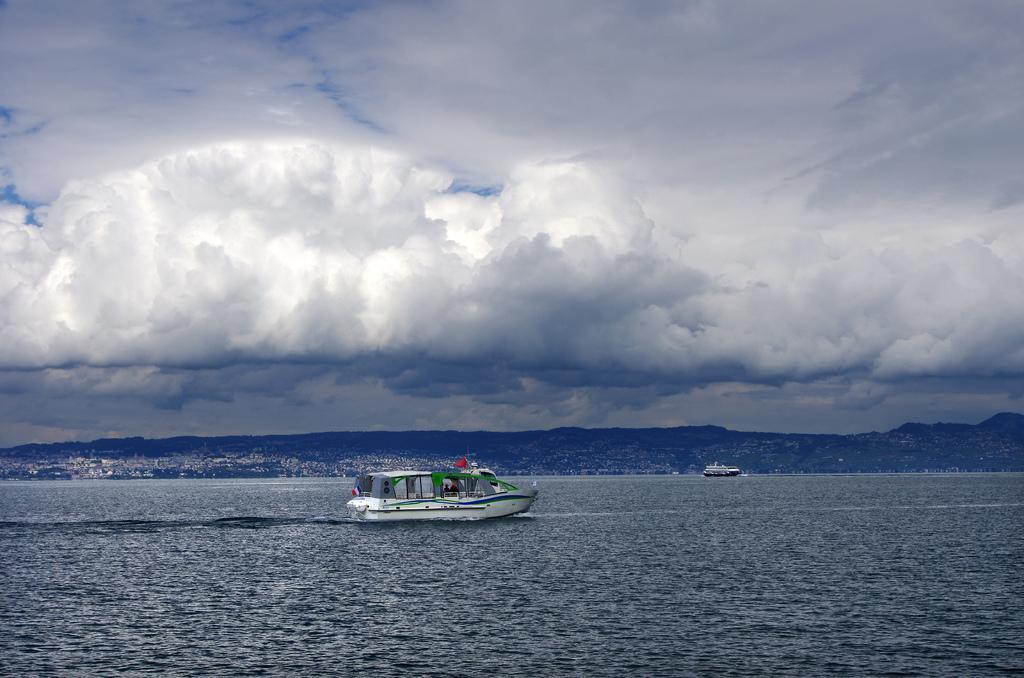How would you summarize this image in a sentence or two? In the middle a ship is moving in this water. These are the clouds. 